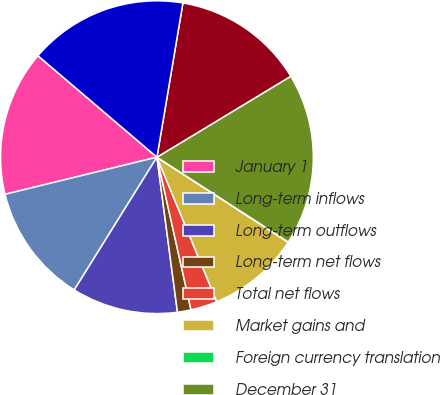Convert chart. <chart><loc_0><loc_0><loc_500><loc_500><pie_chart><fcel>January 1<fcel>Long-term inflows<fcel>Long-term outflows<fcel>Long-term net flows<fcel>Total net flows<fcel>Market gains and<fcel>Foreign currency translation<fcel>December 31<fcel>Average long-term AUM<fcel>Average AUM<nl><fcel>15.05%<fcel>12.32%<fcel>10.96%<fcel>1.4%<fcel>2.76%<fcel>9.59%<fcel>0.03%<fcel>17.78%<fcel>13.69%<fcel>16.42%<nl></chart> 